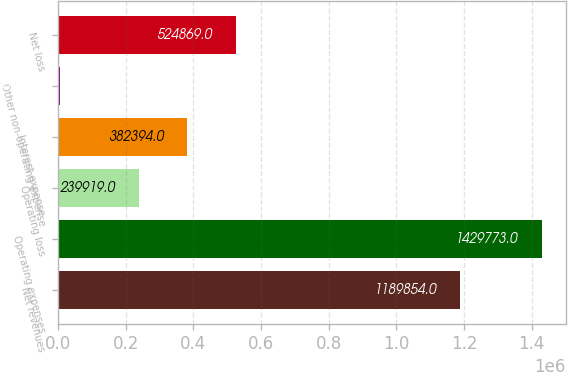<chart> <loc_0><loc_0><loc_500><loc_500><bar_chart><fcel>Net revenues<fcel>Operating expenses<fcel>Operating loss<fcel>Interest expense<fcel>Other non-operating expense<fcel>Net loss<nl><fcel>1.18985e+06<fcel>1.42977e+06<fcel>239919<fcel>382394<fcel>5023<fcel>524869<nl></chart> 